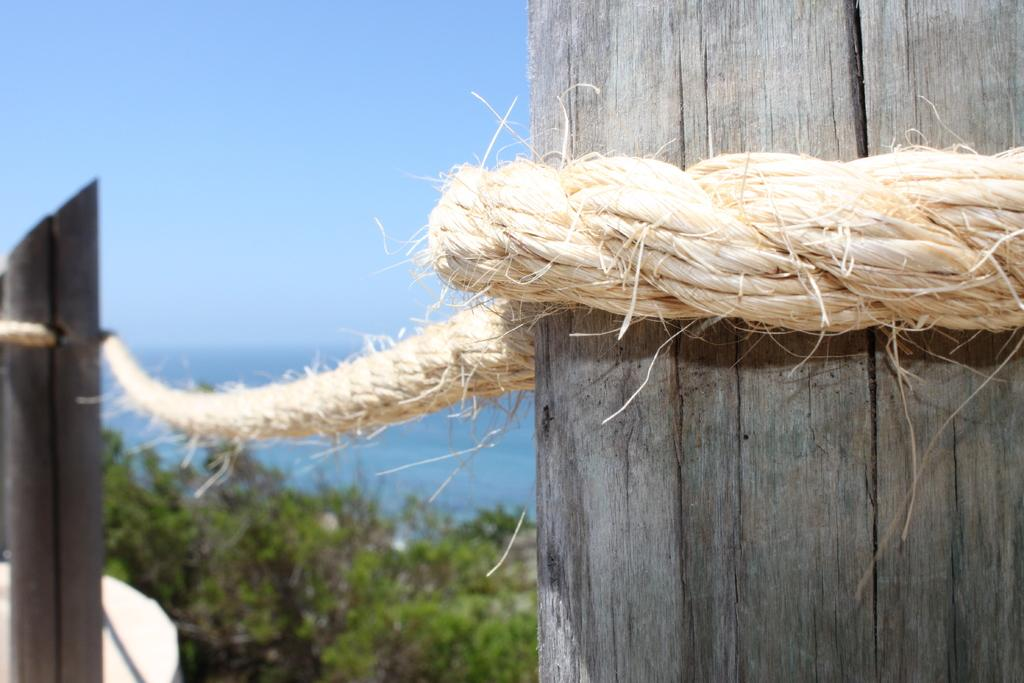What type of material is used to create the poles in the image? The poles in the image are made of wood. How are the wooden poles connected or secured? The wooden poles are tied with a rope. What is the purpose or function of the wooden poles in the image? The wooden poles form a barrier-like structure. What can be seen in the background of the image? There are trees and the sky visible in the background of the image. Is there any quicksand visible in the image? No, there is no quicksand present in the image. What type of salt can be seen on the wooden poles? There is there any salt present in the image? 